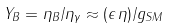<formula> <loc_0><loc_0><loc_500><loc_500>Y _ { B } = { \eta _ { B } } / { \eta _ { \gamma } } \approx ( \epsilon \, \eta ) / { g _ { S M } }</formula> 